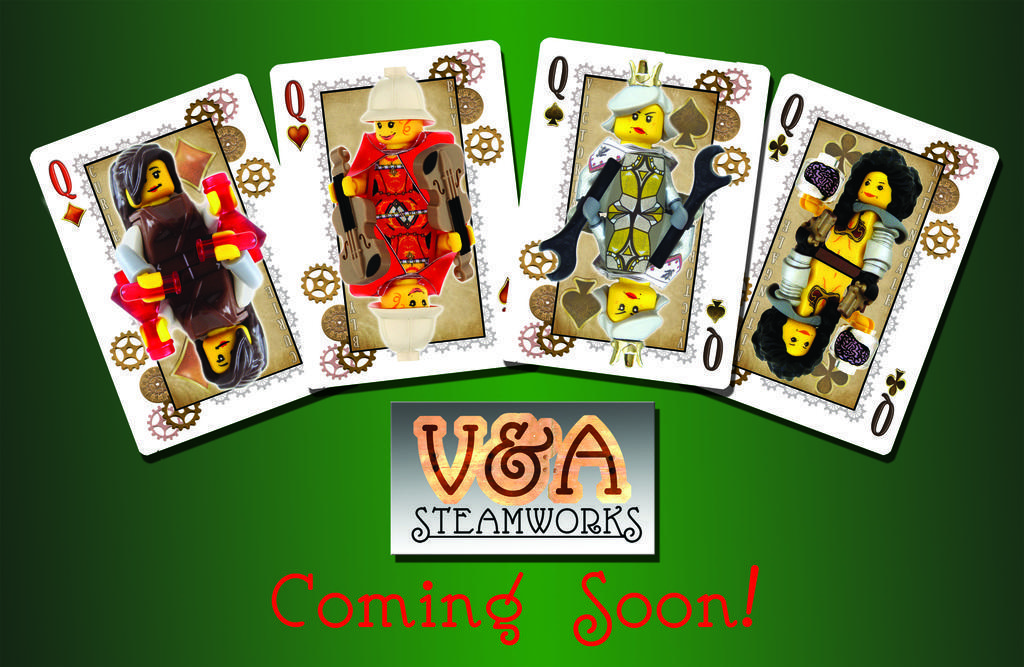Can you describe this image briefly? There are 4 queen cards. Behind that there is a green background. 